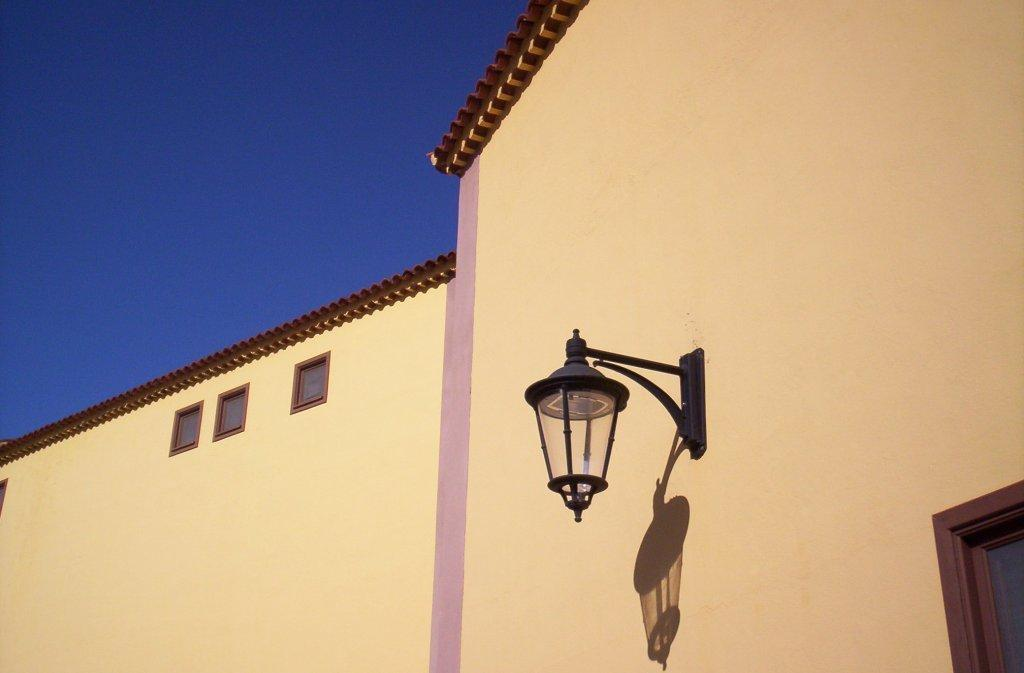What structure is located at the bottom of the image? There is a building at the bottom of the image. What feature can be seen on the building? The building has windows. Is there any illumination visible on the building? Yes, there is a light in the center of the building. What is visible at the top of the image? The sky is visible at the top of the image. Can you see any pigs with horns in the image? There are no pigs or horns present in the image. What type of pan is being used to cook in the image? There is no pan or cooking activity depicted in the image. 